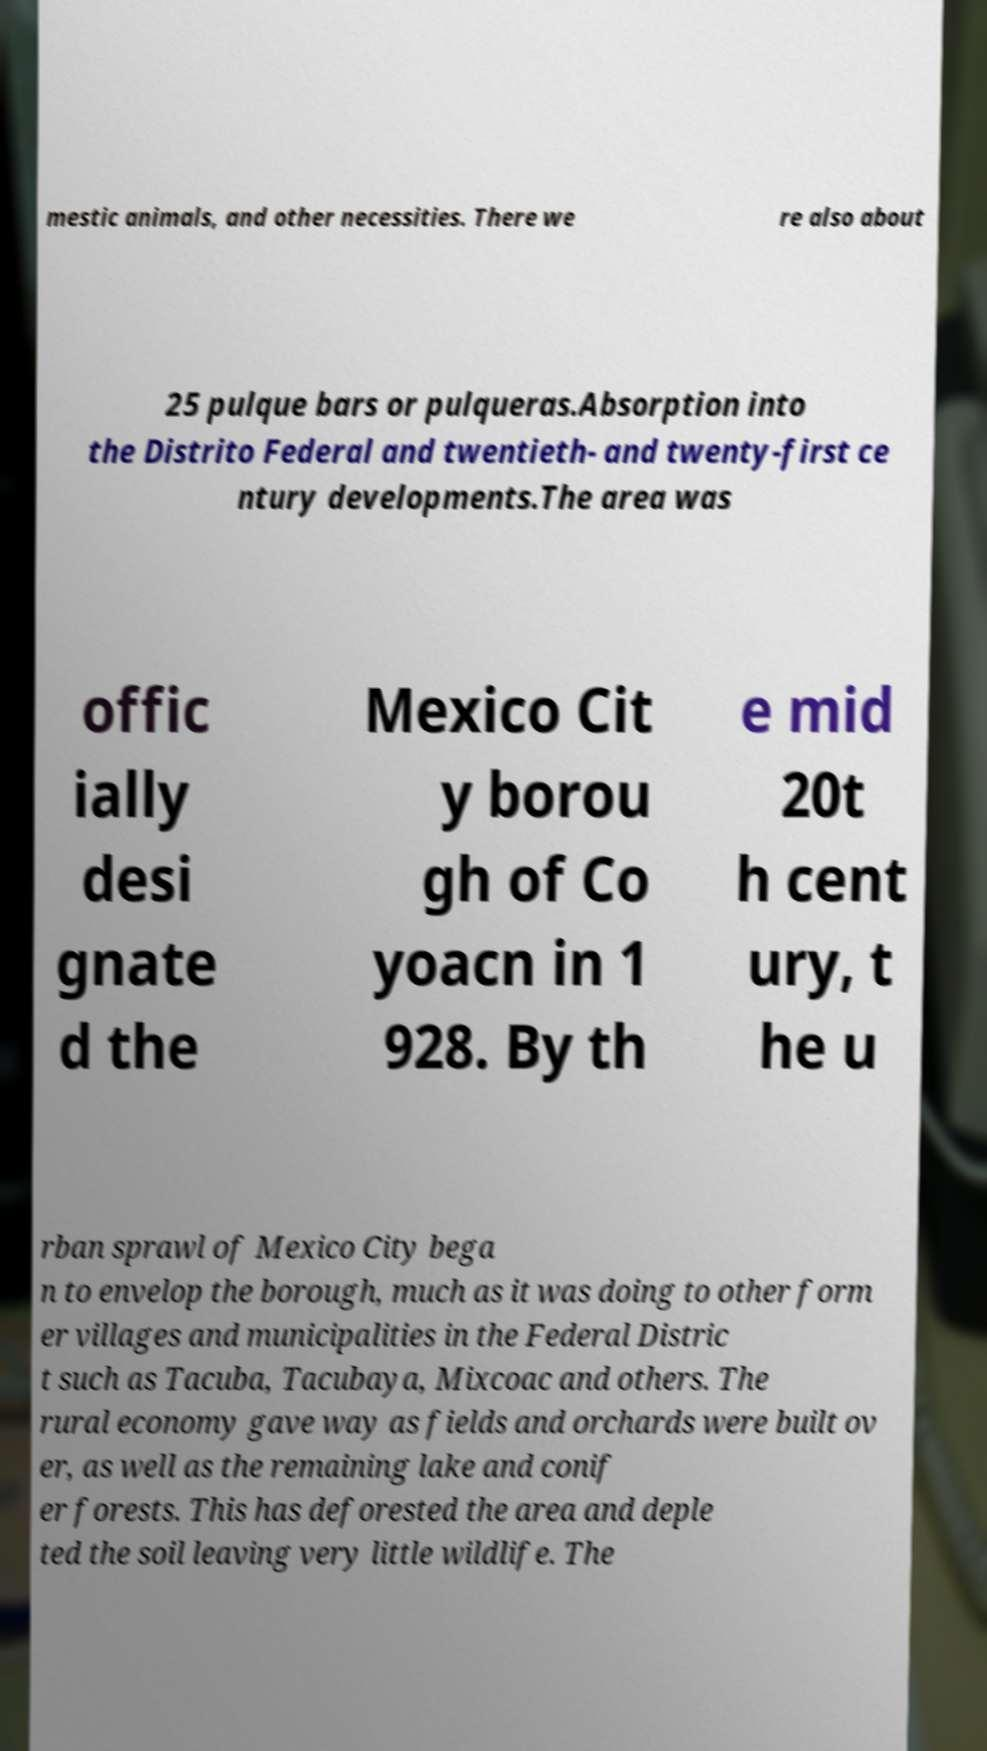Could you extract and type out the text from this image? mestic animals, and other necessities. There we re also about 25 pulque bars or pulqueras.Absorption into the Distrito Federal and twentieth- and twenty-first ce ntury developments.The area was offic ially desi gnate d the Mexico Cit y borou gh of Co yoacn in 1 928. By th e mid 20t h cent ury, t he u rban sprawl of Mexico City bega n to envelop the borough, much as it was doing to other form er villages and municipalities in the Federal Distric t such as Tacuba, Tacubaya, Mixcoac and others. The rural economy gave way as fields and orchards were built ov er, as well as the remaining lake and conif er forests. This has deforested the area and deple ted the soil leaving very little wildlife. The 